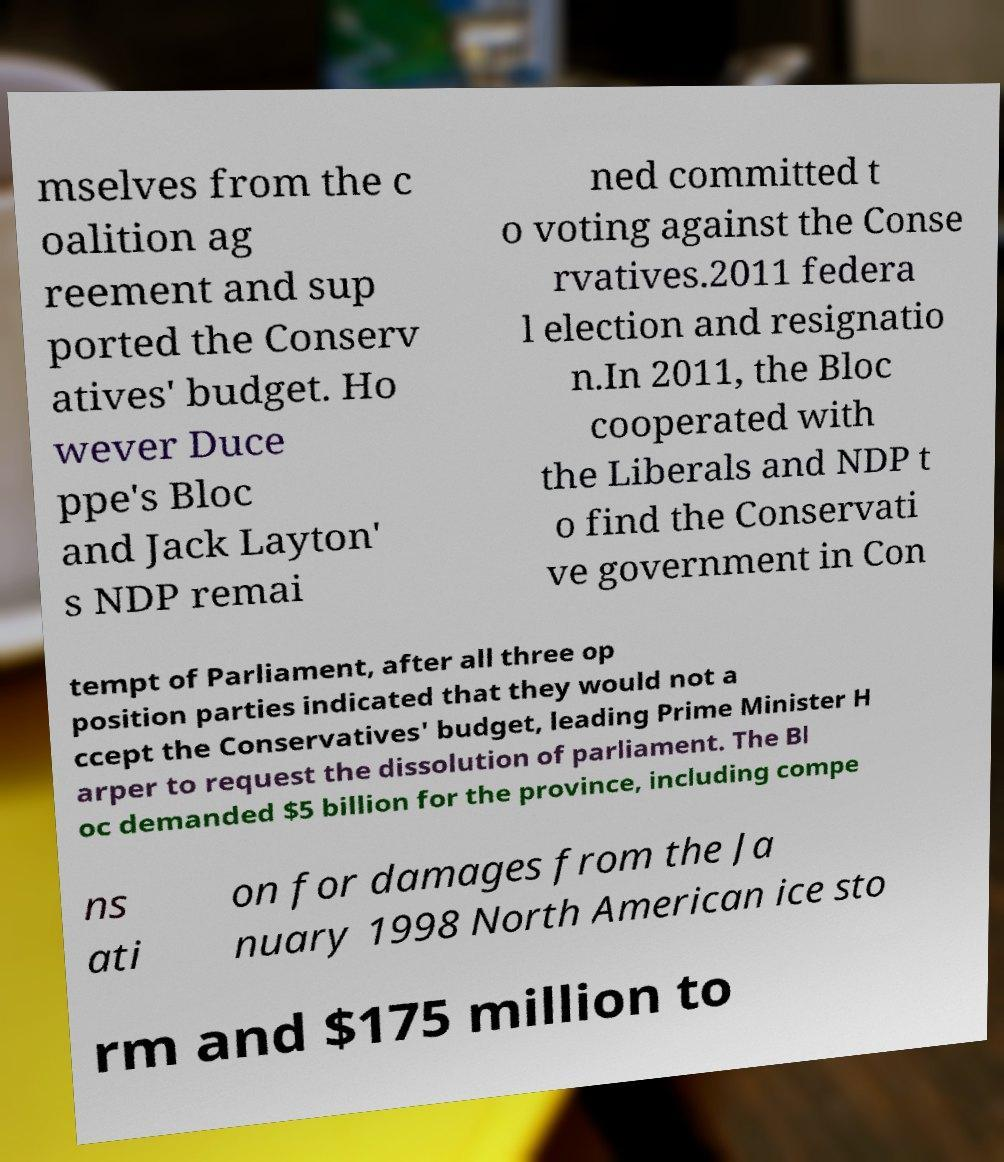Please identify and transcribe the text found in this image. mselves from the c oalition ag reement and sup ported the Conserv atives' budget. Ho wever Duce ppe's Bloc and Jack Layton' s NDP remai ned committed t o voting against the Conse rvatives.2011 federa l election and resignatio n.In 2011, the Bloc cooperated with the Liberals and NDP t o find the Conservati ve government in Con tempt of Parliament, after all three op position parties indicated that they would not a ccept the Conservatives' budget, leading Prime Minister H arper to request the dissolution of parliament. The Bl oc demanded $5 billion for the province, including compe ns ati on for damages from the Ja nuary 1998 North American ice sto rm and $175 million to 